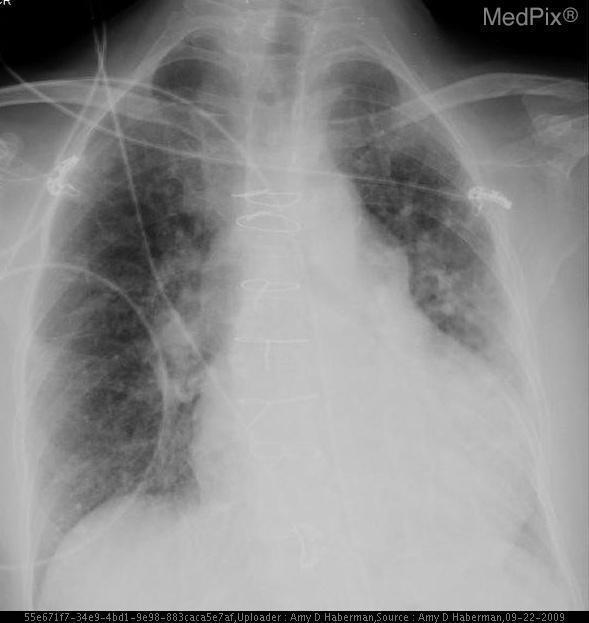Is there an ng tube present?
Write a very short answer. Yes. Can a pulmonary mass be appreciated?
Short answer required. No. Is a pulmonary mass present?
Quick response, please. No. Is there anything abnormal about the heart size?
Write a very short answer. Yes. Is the heart enlarged?
Give a very brief answer. Yes. Is there a right-sided pleural effusion?
Be succinct. No. Is there an effusion present on the right-side?
Keep it brief. No. 